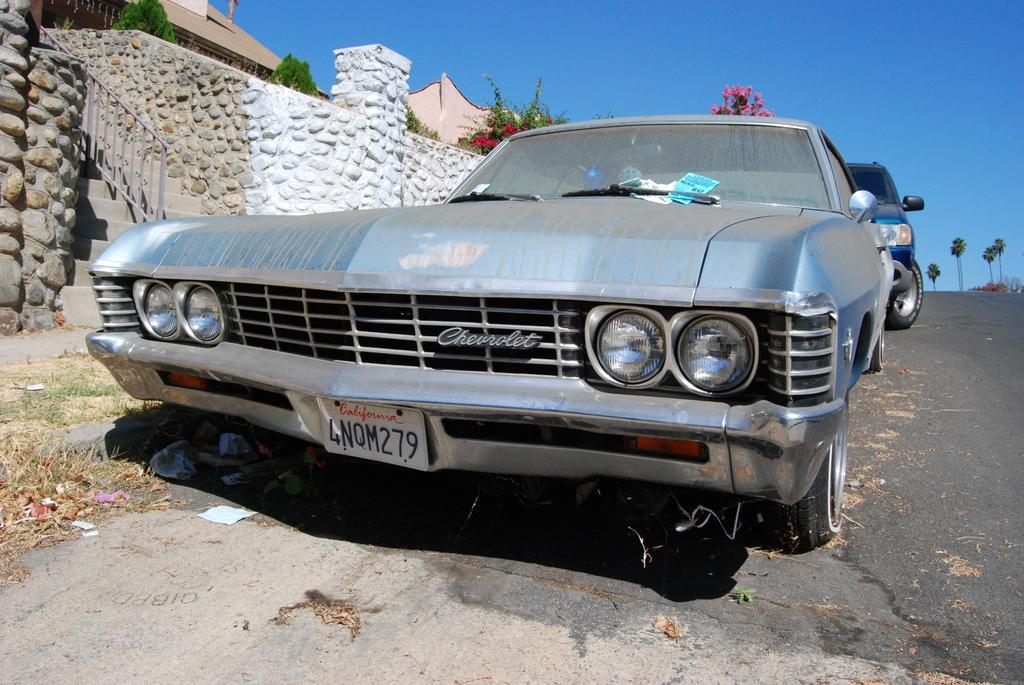Could you give a brief overview of what you see in this image? In the center of the image there are vehicles on the road. To the left side of the image there is a building. There is a wall. In the background of the image there are trees. There is sky. 